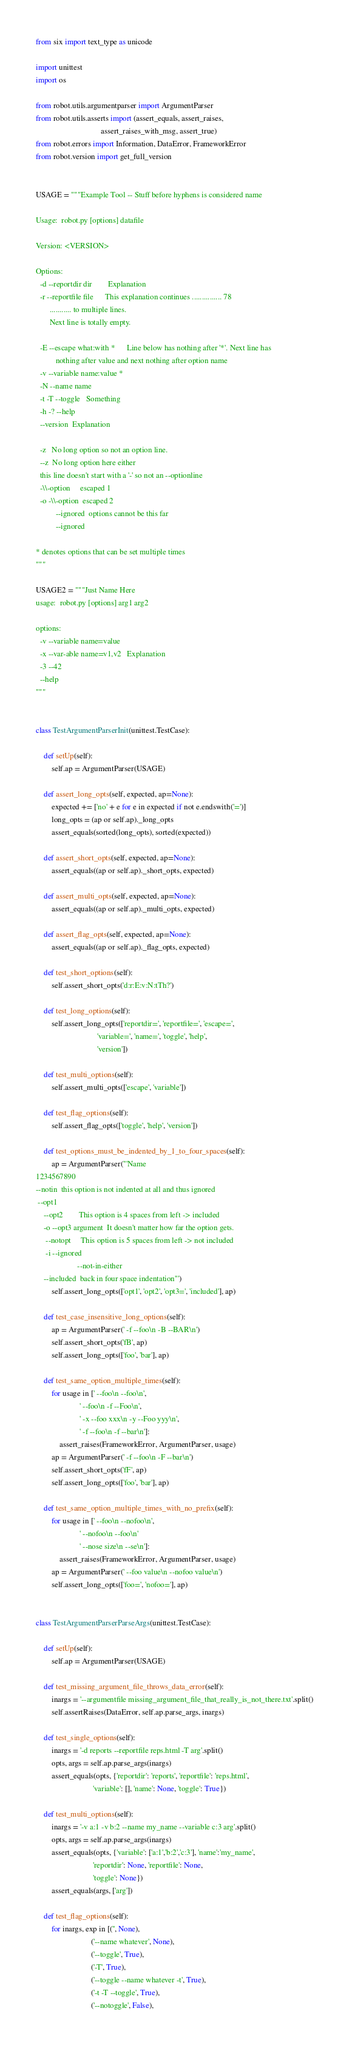Convert code to text. <code><loc_0><loc_0><loc_500><loc_500><_Python_>from six import text_type as unicode

import unittest
import os

from robot.utils.argumentparser import ArgumentParser
from robot.utils.asserts import (assert_equals, assert_raises,
                                 assert_raises_with_msg, assert_true)
from robot.errors import Information, DataError, FrameworkError
from robot.version import get_full_version


USAGE = """Example Tool -- Stuff before hyphens is considered name

Usage:  robot.py [options] datafile

Version: <VERSION>

Options:
  -d --reportdir dir        Explanation
  -r --reportfile file      This explanation continues ............... 78
       ........... to multiple lines.
       Next line is totally empty.

  -E --escape what:with *      Line below has nothing after '*'. Next line has
          nothing after value and next nothing after option name
  -v --variable name:value *
  -N --name name
  -t -T --toggle   Something
  -h -? --help
  --version  Explanation

  -z   No long option so not an option line.
  --z  No long option here either
  this line doesn't start with a '-' so not an --optionline
  -\\-option     escaped 1
  -o -\\-option  escaped 2
          --ignored  options cannot be this far
          --ignored

* denotes options that can be set multiple times
"""

USAGE2 = """Just Name Here
usage:  robot.py [options] arg1 arg2

options:
  -v --variable name=value
  -x --var-able name=v1,v2   Explanation
  -3 --42
  --help
"""


class TestArgumentParserInit(unittest.TestCase):

    def setUp(self):
        self.ap = ArgumentParser(USAGE)

    def assert_long_opts(self, expected, ap=None):
        expected += ['no' + e for e in expected if not e.endswith('=')]
        long_opts = (ap or self.ap)._long_opts
        assert_equals(sorted(long_opts), sorted(expected))

    def assert_short_opts(self, expected, ap=None):
        assert_equals((ap or self.ap)._short_opts, expected)

    def assert_multi_opts(self, expected, ap=None):
        assert_equals((ap or self.ap)._multi_opts, expected)

    def assert_flag_opts(self, expected, ap=None):
        assert_equals((ap or self.ap)._flag_opts, expected)

    def test_short_options(self):
        self.assert_short_opts('d:r:E:v:N:tTh?')

    def test_long_options(self):
        self.assert_long_opts(['reportdir=', 'reportfile=', 'escape=',
                               'variable=', 'name=', 'toggle', 'help',
                               'version'])

    def test_multi_options(self):
        self.assert_multi_opts(['escape', 'variable'])

    def test_flag_options(self):
        self.assert_flag_opts(['toggle', 'help', 'version'])

    def test_options_must_be_indented_by_1_to_four_spaces(self):
        ap = ArgumentParser('''Name
1234567890
--notin  this option is not indented at all and thus ignored
 --opt1
    --opt2        This option is 4 spaces from left -> included
    -o --opt3 argument  It doesn't matter how far the option gets.
     --notopt     This option is 5 spaces from left -> not included
     -i --ignored
                     --not-in-either
    --included  back in four space indentation''')
        self.assert_long_opts(['opt1', 'opt2', 'opt3=', 'included'], ap)

    def test_case_insensitive_long_options(self):
        ap = ArgumentParser(' -f --foo\n -B --BAR\n')
        self.assert_short_opts('fB', ap)
        self.assert_long_opts(['foo', 'bar'], ap)

    def test_same_option_multiple_times(self):
        for usage in [' --foo\n --foo\n',
                      ' --foo\n -f --Foo\n',
                      ' -x --foo xxx\n -y --Foo yyy\n',
                      ' -f --foo\n -f --bar\n']:
            assert_raises(FrameworkError, ArgumentParser, usage)
        ap = ArgumentParser(' -f --foo\n -F --bar\n')
        self.assert_short_opts('fF', ap)
        self.assert_long_opts(['foo', 'bar'], ap)

    def test_same_option_multiple_times_with_no_prefix(self):
        for usage in [' --foo\n --nofoo\n',
                      ' --nofoo\n --foo\n'
                      ' --nose size\n --se\n']:
            assert_raises(FrameworkError, ArgumentParser, usage)
        ap = ArgumentParser(' --foo value\n --nofoo value\n')
        self.assert_long_opts(['foo=', 'nofoo='], ap)


class TestArgumentParserParseArgs(unittest.TestCase):

    def setUp(self):
        self.ap = ArgumentParser(USAGE)

    def test_missing_argument_file_throws_data_error(self):
        inargs = '--argumentfile missing_argument_file_that_really_is_not_there.txt'.split()
        self.assertRaises(DataError, self.ap.parse_args, inargs)

    def test_single_options(self):
        inargs = '-d reports --reportfile reps.html -T arg'.split()
        opts, args = self.ap.parse_args(inargs)
        assert_equals(opts, {'reportdir': 'reports', 'reportfile': 'reps.html',
                             'variable': [], 'name': None, 'toggle': True})

    def test_multi_options(self):
        inargs = '-v a:1 -v b:2 --name my_name --variable c:3 arg'.split()
        opts, args = self.ap.parse_args(inargs)
        assert_equals(opts, {'variable': ['a:1','b:2','c:3'], 'name':'my_name',
                             'reportdir': None, 'reportfile': None,
                             'toggle': None})
        assert_equals(args, ['arg'])

    def test_flag_options(self):
        for inargs, exp in [('', None),
                            ('--name whatever', None),
                            ('--toggle', True),
                            ('-T', True),
                            ('--toggle --name whatever -t', True),
                            ('-t -T --toggle', True),
                            ('--notoggle', False),</code> 